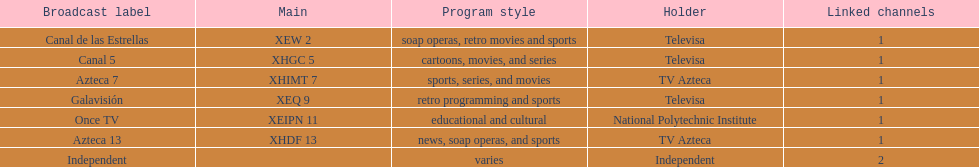Write the full table. {'header': ['Broadcast label', 'Main', 'Program style', 'Holder', 'Linked channels'], 'rows': [['Canal de las Estrellas', 'XEW 2', 'soap operas, retro movies and sports', 'Televisa', '1'], ['Canal 5', 'XHGC 5', 'cartoons, movies, and series', 'Televisa', '1'], ['Azteca 7', 'XHIMT 7', 'sports, series, and movies', 'TV Azteca', '1'], ['Galavisión', 'XEQ 9', 'retro programming and sports', 'Televisa', '1'], ['Once TV', 'XEIPN 11', 'educational and cultural', 'National Polytechnic Institute', '1'], ['Azteca 13', 'XHDF 13', 'news, soap operas, and sports', 'TV Azteca', '1'], ['Independent', '', 'varies', 'Independent', '2']]} Who is the only network owner listed in a consecutive order in the chart? Televisa. 